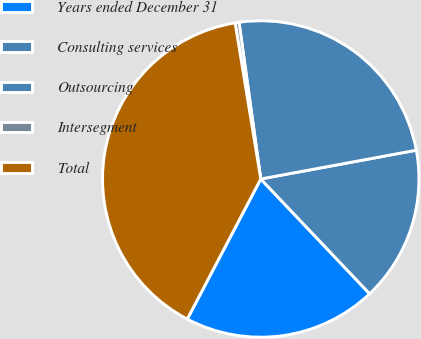Convert chart. <chart><loc_0><loc_0><loc_500><loc_500><pie_chart><fcel>Years ended December 31<fcel>Consulting services<fcel>Outsourcing<fcel>Intersegment<fcel>Total<nl><fcel>19.77%<fcel>15.83%<fcel>24.28%<fcel>0.4%<fcel>39.72%<nl></chart> 